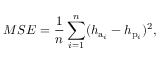Convert formula to latex. <formula><loc_0><loc_0><loc_500><loc_500>M S E = \frac { 1 } { n } \sum _ { i = 1 } ^ { n } ( h _ { a _ { i } } - h _ { p _ { i } } ) ^ { 2 } ,</formula> 